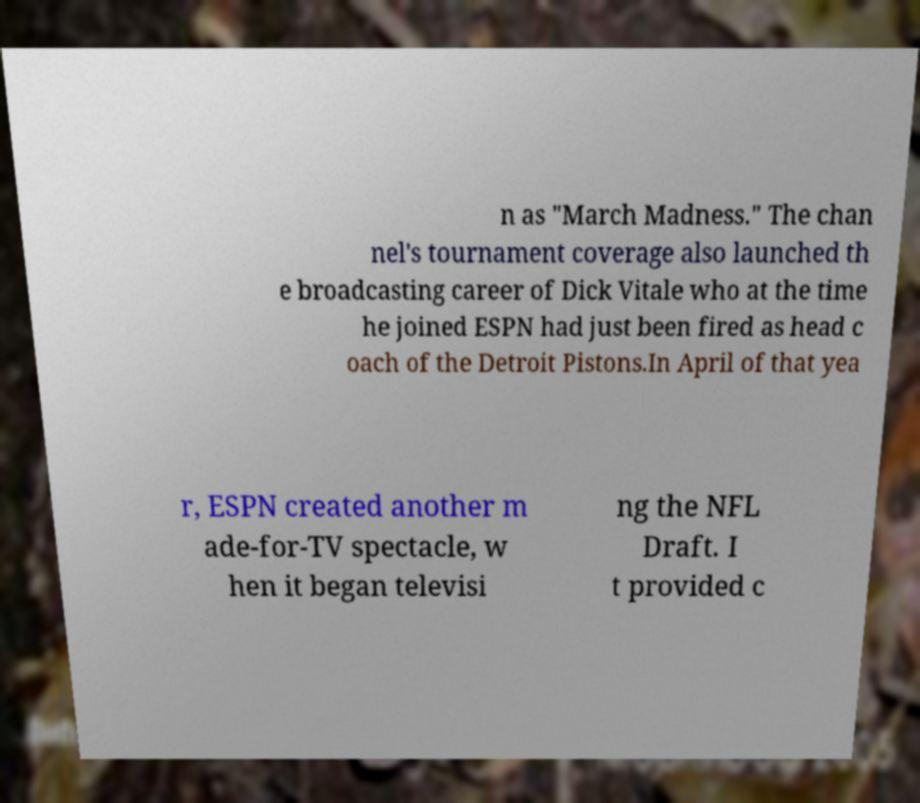Please read and relay the text visible in this image. What does it say? n as "March Madness." The chan nel's tournament coverage also launched th e broadcasting career of Dick Vitale who at the time he joined ESPN had just been fired as head c oach of the Detroit Pistons.In April of that yea r, ESPN created another m ade-for-TV spectacle, w hen it began televisi ng the NFL Draft. I t provided c 